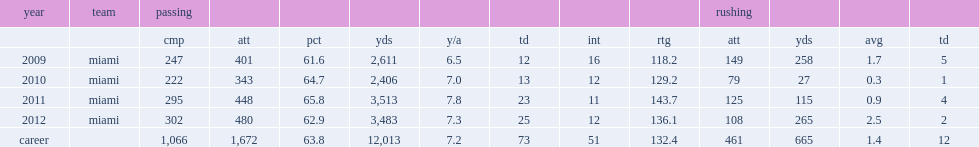How many passing yards did zac dysert finish his sophomore season with? 2406.0. How many touchdowns did zac dysert finish his sophomore season with? 13.0. 